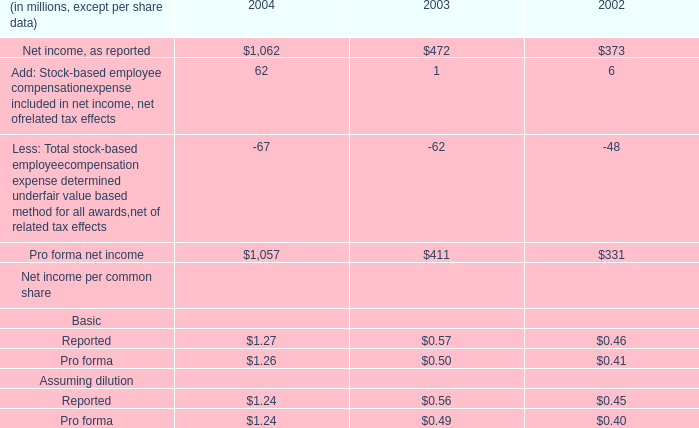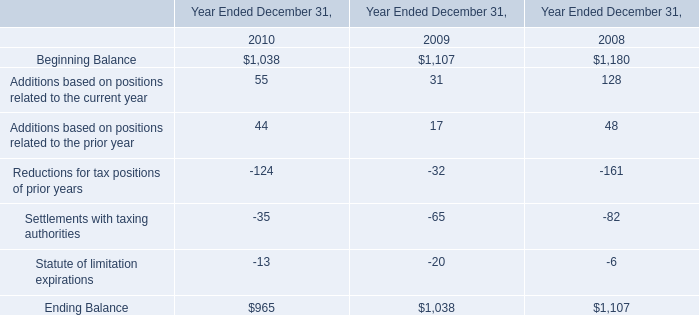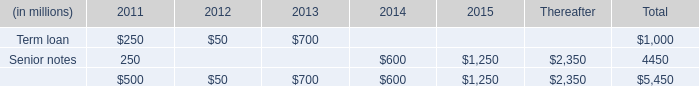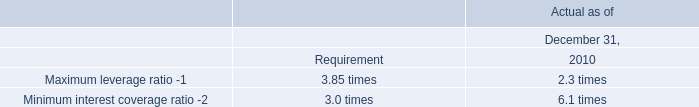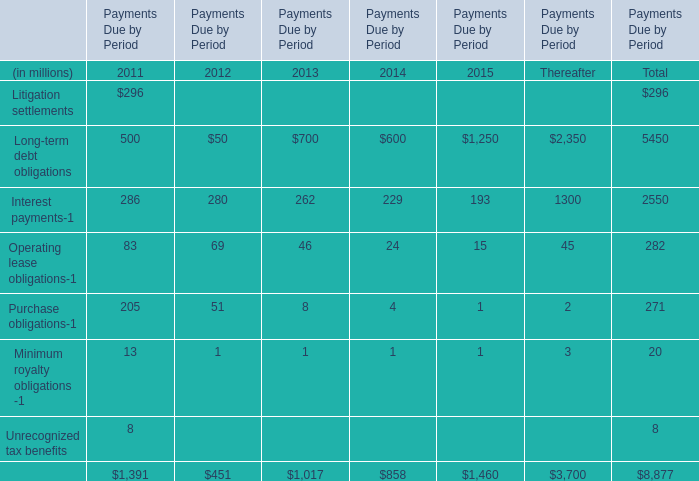What is the sum of Pro forma net income of 2004, Beginning Balance of Year Ended December 31, 2009, and Senior notes of 2015 ? 
Computations: ((1057.0 + 1107.0) + 1250.0)
Answer: 3414.0. 